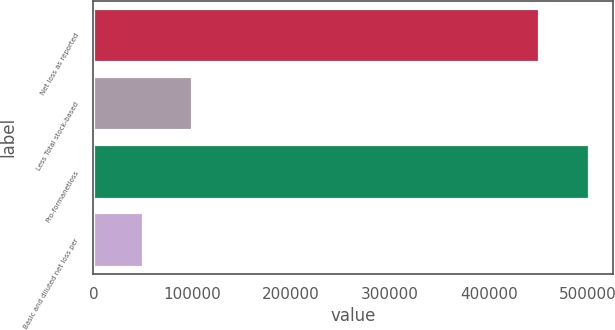<chart> <loc_0><loc_0><loc_500><loc_500><bar_chart><fcel>Net loss as reported<fcel>Less Total stock-based<fcel>Pro-formanetloss<fcel>Basic and diluted net loss per<nl><fcel>450094<fcel>100129<fcel>500634<fcel>50065.5<nl></chart> 